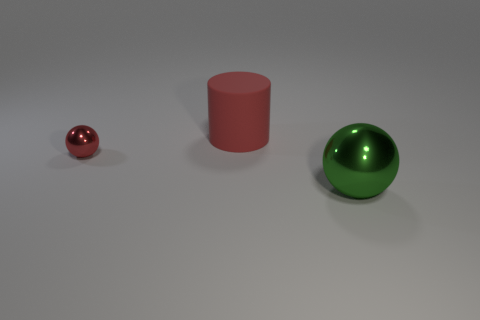Add 2 small red shiny spheres. How many objects exist? 5 Subtract 1 cylinders. How many cylinders are left? 0 Subtract all cyan spheres. Subtract all blue cubes. How many spheres are left? 2 Subtract all gray cylinders. How many gray balls are left? 0 Subtract all tiny red things. Subtract all small red metallic things. How many objects are left? 1 Add 1 small red metallic balls. How many small red metallic balls are left? 2 Add 1 tiny blue metallic balls. How many tiny blue metallic balls exist? 1 Subtract 1 red cylinders. How many objects are left? 2 Subtract all cylinders. How many objects are left? 2 